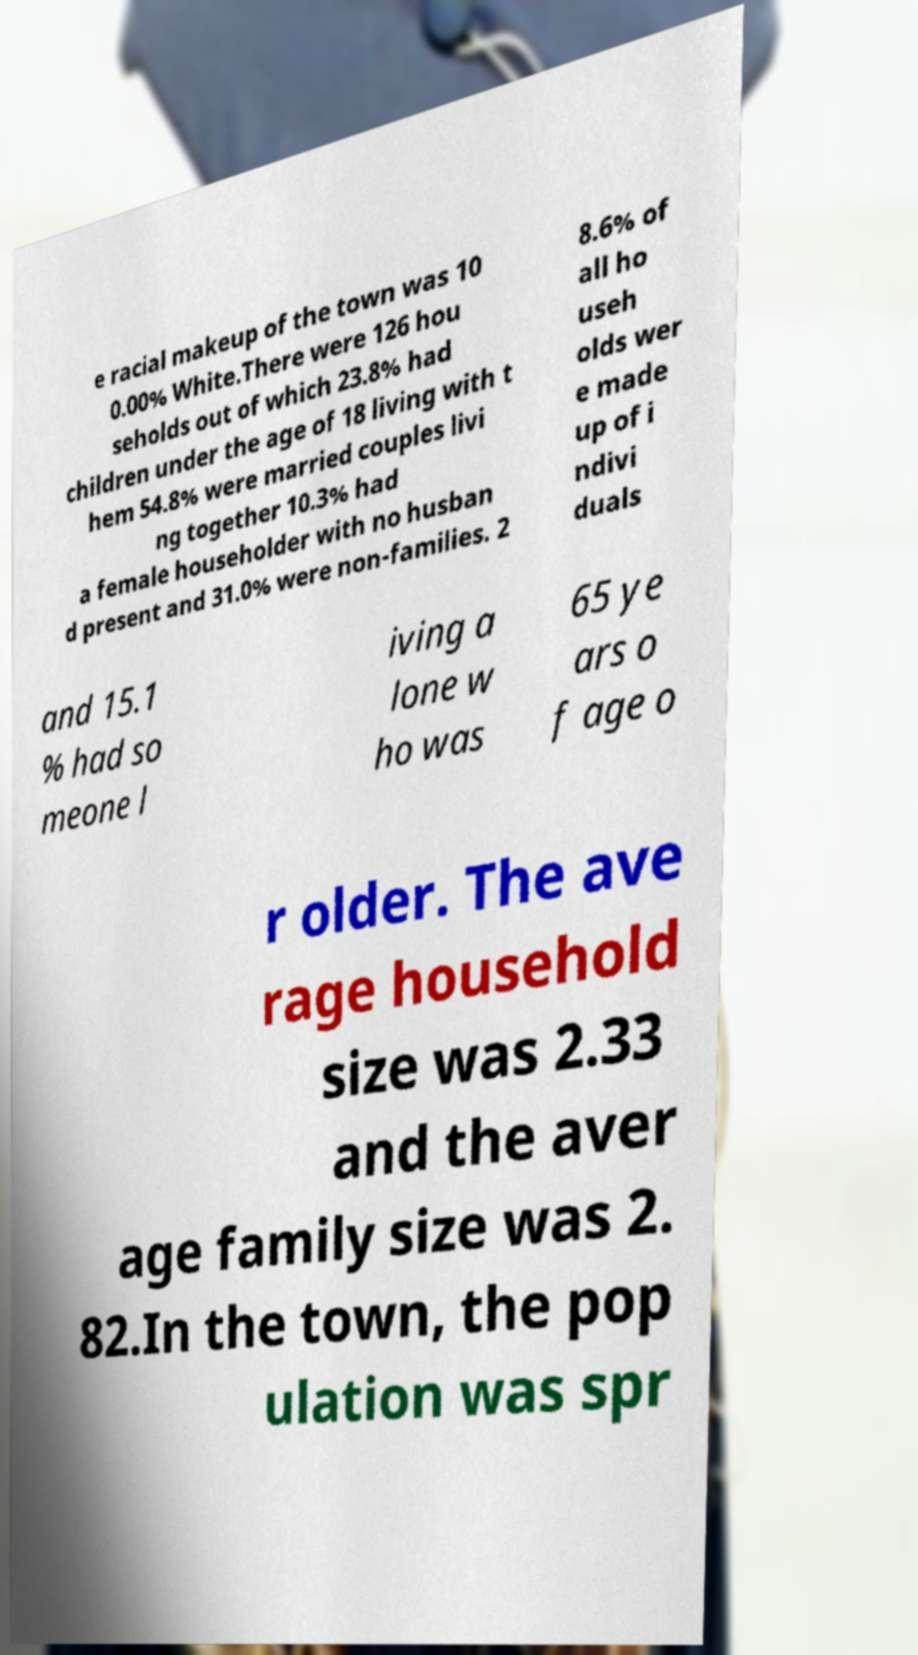Can you read and provide the text displayed in the image?This photo seems to have some interesting text. Can you extract and type it out for me? e racial makeup of the town was 10 0.00% White.There were 126 hou seholds out of which 23.8% had children under the age of 18 living with t hem 54.8% were married couples livi ng together 10.3% had a female householder with no husban d present and 31.0% were non-families. 2 8.6% of all ho useh olds wer e made up of i ndivi duals and 15.1 % had so meone l iving a lone w ho was 65 ye ars o f age o r older. The ave rage household size was 2.33 and the aver age family size was 2. 82.In the town, the pop ulation was spr 